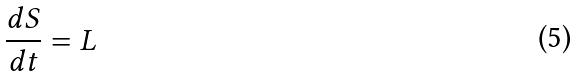<formula> <loc_0><loc_0><loc_500><loc_500>\frac { d S } { d t } = L</formula> 